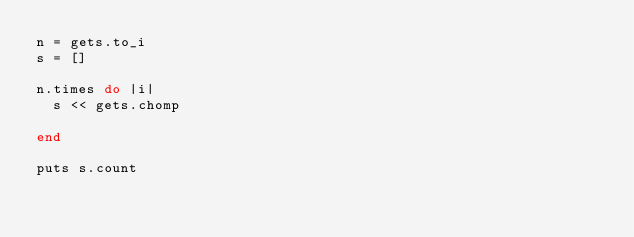Convert code to text. <code><loc_0><loc_0><loc_500><loc_500><_Ruby_>n = gets.to_i
s = []

n.times do |i|
  s << gets.chomp

end

puts s.count
</code> 